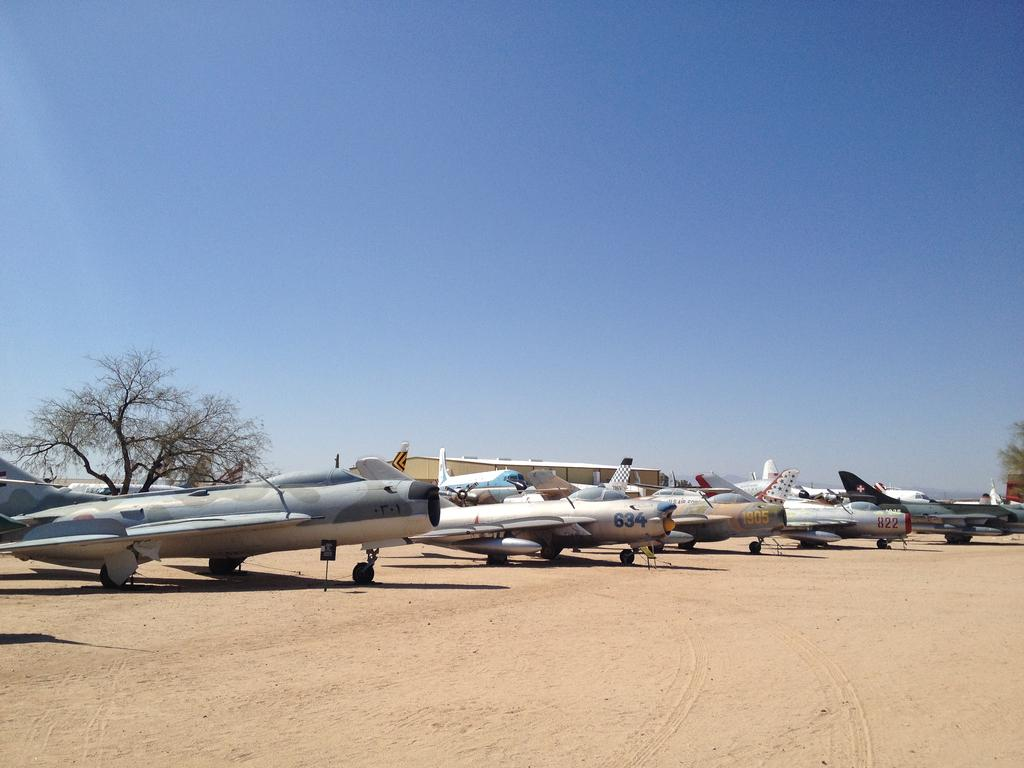What is at the bottom of the image? There is sand at the bottom of the image. What can be seen in the middle of the image? There are aircrafts in the middle of the image. What structure is visible in the background of the image? There is a shed visible in the background of the image. What is visible at the top of the image? The sky is visible at the top of the image. What is the chin of the aircraft doing in the image? There is no chin of an aircraft present in the image. Who is the father of the shed in the image? The image does not depict a shed with a father; it is a structure and not a living being. 